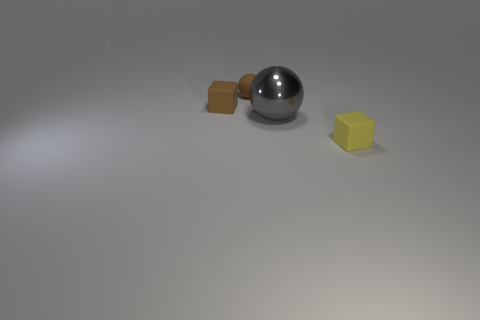Add 1 big gray shiny cubes. How many objects exist? 5 Subtract 0 blue cylinders. How many objects are left? 4 Subtract all small cyan blocks. Subtract all small objects. How many objects are left? 1 Add 3 tiny brown balls. How many tiny brown balls are left? 4 Add 1 large brown rubber blocks. How many large brown rubber blocks exist? 1 